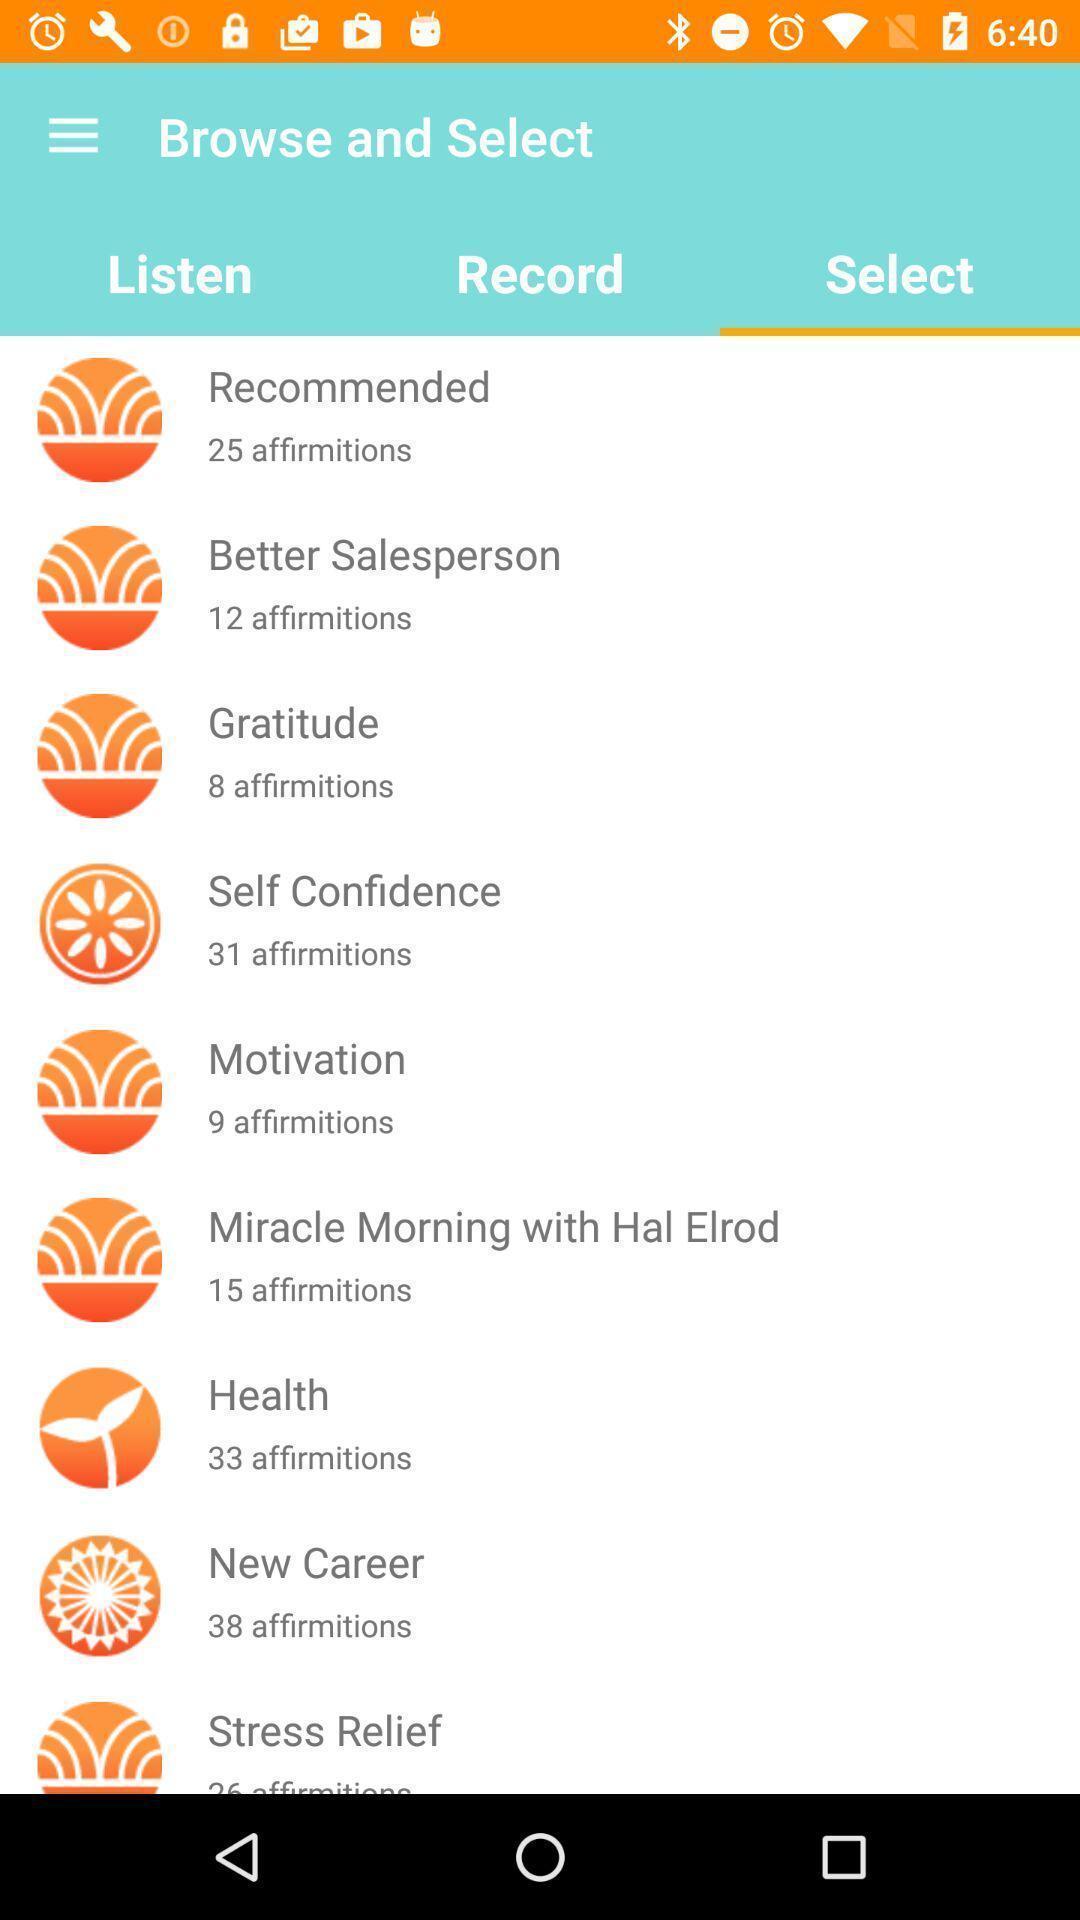Provide a textual representation of this image. Screen displaying the list of options. 